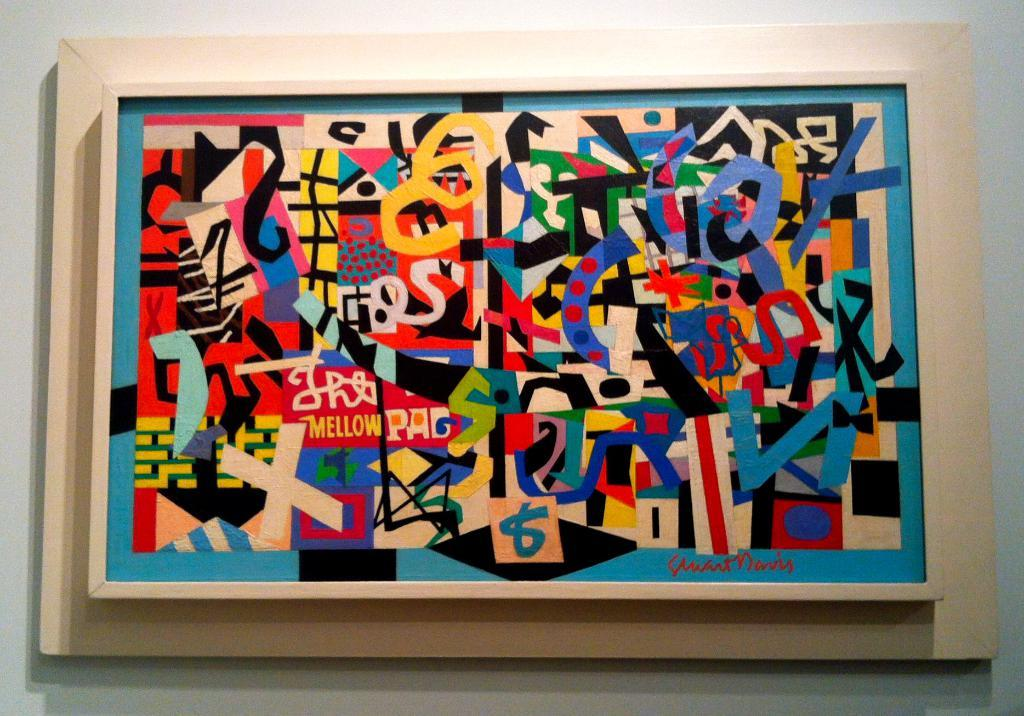<image>
Create a compact narrative representing the image presented. The lower left quadrant has a yellow word of mellow. 